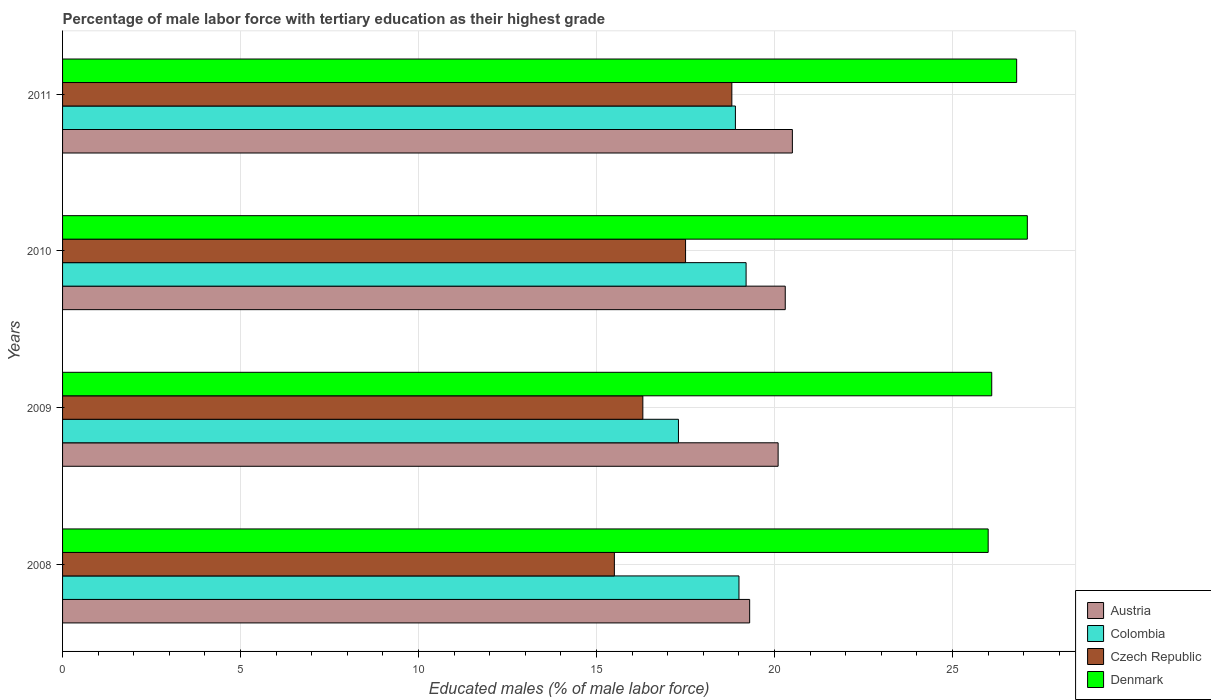How many different coloured bars are there?
Your answer should be very brief. 4. How many groups of bars are there?
Keep it short and to the point. 4. How many bars are there on the 1st tick from the top?
Provide a short and direct response. 4. How many bars are there on the 1st tick from the bottom?
Make the answer very short. 4. What is the percentage of male labor force with tertiary education in Czech Republic in 2011?
Your response must be concise. 18.8. Across all years, what is the maximum percentage of male labor force with tertiary education in Colombia?
Offer a terse response. 19.2. In which year was the percentage of male labor force with tertiary education in Austria minimum?
Your answer should be very brief. 2008. What is the total percentage of male labor force with tertiary education in Austria in the graph?
Make the answer very short. 80.2. What is the difference between the percentage of male labor force with tertiary education in Czech Republic in 2008 and that in 2009?
Your response must be concise. -0.8. What is the difference between the percentage of male labor force with tertiary education in Austria in 2009 and the percentage of male labor force with tertiary education in Czech Republic in 2008?
Provide a short and direct response. 4.6. What is the average percentage of male labor force with tertiary education in Denmark per year?
Make the answer very short. 26.5. In the year 2008, what is the difference between the percentage of male labor force with tertiary education in Denmark and percentage of male labor force with tertiary education in Colombia?
Provide a short and direct response. 7. In how many years, is the percentage of male labor force with tertiary education in Czech Republic greater than 20 %?
Ensure brevity in your answer.  0. What is the ratio of the percentage of male labor force with tertiary education in Czech Republic in 2008 to that in 2011?
Provide a short and direct response. 0.82. Is the percentage of male labor force with tertiary education in Denmark in 2008 less than that in 2009?
Ensure brevity in your answer.  Yes. What is the difference between the highest and the second highest percentage of male labor force with tertiary education in Austria?
Offer a terse response. 0.2. What is the difference between the highest and the lowest percentage of male labor force with tertiary education in Colombia?
Your answer should be very brief. 1.9. Is the sum of the percentage of male labor force with tertiary education in Denmark in 2008 and 2010 greater than the maximum percentage of male labor force with tertiary education in Colombia across all years?
Your answer should be very brief. Yes. What does the 1st bar from the top in 2009 represents?
Give a very brief answer. Denmark. What does the 1st bar from the bottom in 2008 represents?
Your answer should be very brief. Austria. How many bars are there?
Your answer should be very brief. 16. Are all the bars in the graph horizontal?
Provide a short and direct response. Yes. How many years are there in the graph?
Ensure brevity in your answer.  4. What is the difference between two consecutive major ticks on the X-axis?
Provide a short and direct response. 5. Are the values on the major ticks of X-axis written in scientific E-notation?
Provide a succinct answer. No. Does the graph contain any zero values?
Ensure brevity in your answer.  No. Does the graph contain grids?
Ensure brevity in your answer.  Yes. Where does the legend appear in the graph?
Make the answer very short. Bottom right. How many legend labels are there?
Give a very brief answer. 4. How are the legend labels stacked?
Provide a succinct answer. Vertical. What is the title of the graph?
Keep it short and to the point. Percentage of male labor force with tertiary education as their highest grade. Does "Cyprus" appear as one of the legend labels in the graph?
Make the answer very short. No. What is the label or title of the X-axis?
Keep it short and to the point. Educated males (% of male labor force). What is the Educated males (% of male labor force) in Austria in 2008?
Provide a short and direct response. 19.3. What is the Educated males (% of male labor force) of Denmark in 2008?
Give a very brief answer. 26. What is the Educated males (% of male labor force) in Austria in 2009?
Provide a succinct answer. 20.1. What is the Educated males (% of male labor force) in Colombia in 2009?
Your answer should be very brief. 17.3. What is the Educated males (% of male labor force) of Czech Republic in 2009?
Provide a succinct answer. 16.3. What is the Educated males (% of male labor force) in Denmark in 2009?
Keep it short and to the point. 26.1. What is the Educated males (% of male labor force) in Austria in 2010?
Give a very brief answer. 20.3. What is the Educated males (% of male labor force) in Colombia in 2010?
Offer a very short reply. 19.2. What is the Educated males (% of male labor force) of Denmark in 2010?
Your answer should be very brief. 27.1. What is the Educated males (% of male labor force) of Colombia in 2011?
Make the answer very short. 18.9. What is the Educated males (% of male labor force) in Czech Republic in 2011?
Your answer should be very brief. 18.8. What is the Educated males (% of male labor force) of Denmark in 2011?
Your answer should be very brief. 26.8. Across all years, what is the maximum Educated males (% of male labor force) in Austria?
Give a very brief answer. 20.5. Across all years, what is the maximum Educated males (% of male labor force) of Colombia?
Ensure brevity in your answer.  19.2. Across all years, what is the maximum Educated males (% of male labor force) in Czech Republic?
Your response must be concise. 18.8. Across all years, what is the maximum Educated males (% of male labor force) in Denmark?
Give a very brief answer. 27.1. Across all years, what is the minimum Educated males (% of male labor force) of Austria?
Your response must be concise. 19.3. Across all years, what is the minimum Educated males (% of male labor force) of Colombia?
Provide a short and direct response. 17.3. What is the total Educated males (% of male labor force) of Austria in the graph?
Provide a short and direct response. 80.2. What is the total Educated males (% of male labor force) in Colombia in the graph?
Ensure brevity in your answer.  74.4. What is the total Educated males (% of male labor force) of Czech Republic in the graph?
Provide a short and direct response. 68.1. What is the total Educated males (% of male labor force) of Denmark in the graph?
Make the answer very short. 106. What is the difference between the Educated males (% of male labor force) of Austria in 2008 and that in 2009?
Ensure brevity in your answer.  -0.8. What is the difference between the Educated males (% of male labor force) in Colombia in 2008 and that in 2009?
Keep it short and to the point. 1.7. What is the difference between the Educated males (% of male labor force) of Czech Republic in 2008 and that in 2009?
Provide a short and direct response. -0.8. What is the difference between the Educated males (% of male labor force) of Denmark in 2008 and that in 2009?
Ensure brevity in your answer.  -0.1. What is the difference between the Educated males (% of male labor force) of Austria in 2008 and that in 2010?
Your response must be concise. -1. What is the difference between the Educated males (% of male labor force) of Colombia in 2008 and that in 2010?
Provide a succinct answer. -0.2. What is the difference between the Educated males (% of male labor force) of Czech Republic in 2008 and that in 2010?
Your response must be concise. -2. What is the difference between the Educated males (% of male labor force) in Denmark in 2008 and that in 2010?
Provide a short and direct response. -1.1. What is the difference between the Educated males (% of male labor force) in Austria in 2008 and that in 2011?
Offer a very short reply. -1.2. What is the difference between the Educated males (% of male labor force) of Colombia in 2008 and that in 2011?
Make the answer very short. 0.1. What is the difference between the Educated males (% of male labor force) of Czech Republic in 2008 and that in 2011?
Provide a short and direct response. -3.3. What is the difference between the Educated males (% of male labor force) in Austria in 2009 and that in 2010?
Ensure brevity in your answer.  -0.2. What is the difference between the Educated males (% of male labor force) in Czech Republic in 2009 and that in 2010?
Ensure brevity in your answer.  -1.2. What is the difference between the Educated males (% of male labor force) in Denmark in 2009 and that in 2010?
Offer a terse response. -1. What is the difference between the Educated males (% of male labor force) in Denmark in 2009 and that in 2011?
Offer a very short reply. -0.7. What is the difference between the Educated males (% of male labor force) in Colombia in 2008 and the Educated males (% of male labor force) in Denmark in 2009?
Ensure brevity in your answer.  -7.1. What is the difference between the Educated males (% of male labor force) in Austria in 2008 and the Educated males (% of male labor force) in Colombia in 2010?
Make the answer very short. 0.1. What is the difference between the Educated males (% of male labor force) in Austria in 2008 and the Educated males (% of male labor force) in Denmark in 2010?
Make the answer very short. -7.8. What is the difference between the Educated males (% of male labor force) in Colombia in 2008 and the Educated males (% of male labor force) in Czech Republic in 2010?
Ensure brevity in your answer.  1.5. What is the difference between the Educated males (% of male labor force) of Colombia in 2008 and the Educated males (% of male labor force) of Denmark in 2010?
Your answer should be compact. -8.1. What is the difference between the Educated males (% of male labor force) in Czech Republic in 2008 and the Educated males (% of male labor force) in Denmark in 2010?
Your answer should be very brief. -11.6. What is the difference between the Educated males (% of male labor force) in Czech Republic in 2008 and the Educated males (% of male labor force) in Denmark in 2011?
Give a very brief answer. -11.3. What is the difference between the Educated males (% of male labor force) of Austria in 2009 and the Educated males (% of male labor force) of Colombia in 2010?
Give a very brief answer. 0.9. What is the difference between the Educated males (% of male labor force) in Colombia in 2009 and the Educated males (% of male labor force) in Czech Republic in 2010?
Your response must be concise. -0.2. What is the difference between the Educated males (% of male labor force) in Colombia in 2009 and the Educated males (% of male labor force) in Denmark in 2010?
Your response must be concise. -9.8. What is the difference between the Educated males (% of male labor force) in Austria in 2009 and the Educated males (% of male labor force) in Czech Republic in 2011?
Provide a short and direct response. 1.3. What is the difference between the Educated males (% of male labor force) in Colombia in 2009 and the Educated males (% of male labor force) in Czech Republic in 2011?
Your answer should be very brief. -1.5. What is the difference between the Educated males (% of male labor force) of Colombia in 2009 and the Educated males (% of male labor force) of Denmark in 2011?
Offer a very short reply. -9.5. What is the difference between the Educated males (% of male labor force) in Austria in 2010 and the Educated males (% of male labor force) in Colombia in 2011?
Your answer should be very brief. 1.4. What is the difference between the Educated males (% of male labor force) in Austria in 2010 and the Educated males (% of male labor force) in Denmark in 2011?
Make the answer very short. -6.5. What is the difference between the Educated males (% of male labor force) in Colombia in 2010 and the Educated males (% of male labor force) in Czech Republic in 2011?
Your response must be concise. 0.4. What is the difference between the Educated males (% of male labor force) of Colombia in 2010 and the Educated males (% of male labor force) of Denmark in 2011?
Provide a succinct answer. -7.6. What is the average Educated males (% of male labor force) in Austria per year?
Offer a terse response. 20.05. What is the average Educated males (% of male labor force) in Czech Republic per year?
Your answer should be compact. 17.02. What is the average Educated males (% of male labor force) in Denmark per year?
Provide a succinct answer. 26.5. In the year 2008, what is the difference between the Educated males (% of male labor force) in Colombia and Educated males (% of male labor force) in Czech Republic?
Offer a terse response. 3.5. In the year 2008, what is the difference between the Educated males (% of male labor force) of Colombia and Educated males (% of male labor force) of Denmark?
Ensure brevity in your answer.  -7. In the year 2008, what is the difference between the Educated males (% of male labor force) in Czech Republic and Educated males (% of male labor force) in Denmark?
Keep it short and to the point. -10.5. In the year 2009, what is the difference between the Educated males (% of male labor force) in Austria and Educated males (% of male labor force) in Denmark?
Provide a succinct answer. -6. In the year 2009, what is the difference between the Educated males (% of male labor force) of Colombia and Educated males (% of male labor force) of Denmark?
Give a very brief answer. -8.8. In the year 2009, what is the difference between the Educated males (% of male labor force) in Czech Republic and Educated males (% of male labor force) in Denmark?
Your answer should be very brief. -9.8. In the year 2010, what is the difference between the Educated males (% of male labor force) of Austria and Educated males (% of male labor force) of Colombia?
Give a very brief answer. 1.1. In the year 2010, what is the difference between the Educated males (% of male labor force) in Austria and Educated males (% of male labor force) in Czech Republic?
Make the answer very short. 2.8. In the year 2010, what is the difference between the Educated males (% of male labor force) in Colombia and Educated males (% of male labor force) in Czech Republic?
Offer a very short reply. 1.7. In the year 2010, what is the difference between the Educated males (% of male labor force) of Czech Republic and Educated males (% of male labor force) of Denmark?
Ensure brevity in your answer.  -9.6. In the year 2011, what is the difference between the Educated males (% of male labor force) in Austria and Educated males (% of male labor force) in Colombia?
Your response must be concise. 1.6. In the year 2011, what is the difference between the Educated males (% of male labor force) in Austria and Educated males (% of male labor force) in Denmark?
Ensure brevity in your answer.  -6.3. In the year 2011, what is the difference between the Educated males (% of male labor force) of Colombia and Educated males (% of male labor force) of Czech Republic?
Provide a succinct answer. 0.1. In the year 2011, what is the difference between the Educated males (% of male labor force) in Colombia and Educated males (% of male labor force) in Denmark?
Keep it short and to the point. -7.9. In the year 2011, what is the difference between the Educated males (% of male labor force) of Czech Republic and Educated males (% of male labor force) of Denmark?
Provide a succinct answer. -8. What is the ratio of the Educated males (% of male labor force) of Austria in 2008 to that in 2009?
Keep it short and to the point. 0.96. What is the ratio of the Educated males (% of male labor force) of Colombia in 2008 to that in 2009?
Your answer should be very brief. 1.1. What is the ratio of the Educated males (% of male labor force) in Czech Republic in 2008 to that in 2009?
Ensure brevity in your answer.  0.95. What is the ratio of the Educated males (% of male labor force) in Austria in 2008 to that in 2010?
Keep it short and to the point. 0.95. What is the ratio of the Educated males (% of male labor force) in Colombia in 2008 to that in 2010?
Make the answer very short. 0.99. What is the ratio of the Educated males (% of male labor force) in Czech Republic in 2008 to that in 2010?
Give a very brief answer. 0.89. What is the ratio of the Educated males (% of male labor force) in Denmark in 2008 to that in 2010?
Keep it short and to the point. 0.96. What is the ratio of the Educated males (% of male labor force) of Austria in 2008 to that in 2011?
Your answer should be compact. 0.94. What is the ratio of the Educated males (% of male labor force) of Czech Republic in 2008 to that in 2011?
Offer a very short reply. 0.82. What is the ratio of the Educated males (% of male labor force) in Denmark in 2008 to that in 2011?
Give a very brief answer. 0.97. What is the ratio of the Educated males (% of male labor force) in Austria in 2009 to that in 2010?
Keep it short and to the point. 0.99. What is the ratio of the Educated males (% of male labor force) in Colombia in 2009 to that in 2010?
Your response must be concise. 0.9. What is the ratio of the Educated males (% of male labor force) of Czech Republic in 2009 to that in 2010?
Your answer should be compact. 0.93. What is the ratio of the Educated males (% of male labor force) of Denmark in 2009 to that in 2010?
Your answer should be very brief. 0.96. What is the ratio of the Educated males (% of male labor force) of Austria in 2009 to that in 2011?
Offer a very short reply. 0.98. What is the ratio of the Educated males (% of male labor force) in Colombia in 2009 to that in 2011?
Make the answer very short. 0.92. What is the ratio of the Educated males (% of male labor force) in Czech Republic in 2009 to that in 2011?
Make the answer very short. 0.87. What is the ratio of the Educated males (% of male labor force) of Denmark in 2009 to that in 2011?
Give a very brief answer. 0.97. What is the ratio of the Educated males (% of male labor force) of Austria in 2010 to that in 2011?
Ensure brevity in your answer.  0.99. What is the ratio of the Educated males (% of male labor force) of Colombia in 2010 to that in 2011?
Provide a succinct answer. 1.02. What is the ratio of the Educated males (% of male labor force) of Czech Republic in 2010 to that in 2011?
Keep it short and to the point. 0.93. What is the ratio of the Educated males (% of male labor force) of Denmark in 2010 to that in 2011?
Provide a succinct answer. 1.01. What is the difference between the highest and the second highest Educated males (% of male labor force) of Czech Republic?
Your answer should be very brief. 1.3. What is the difference between the highest and the lowest Educated males (% of male labor force) of Czech Republic?
Offer a terse response. 3.3. 